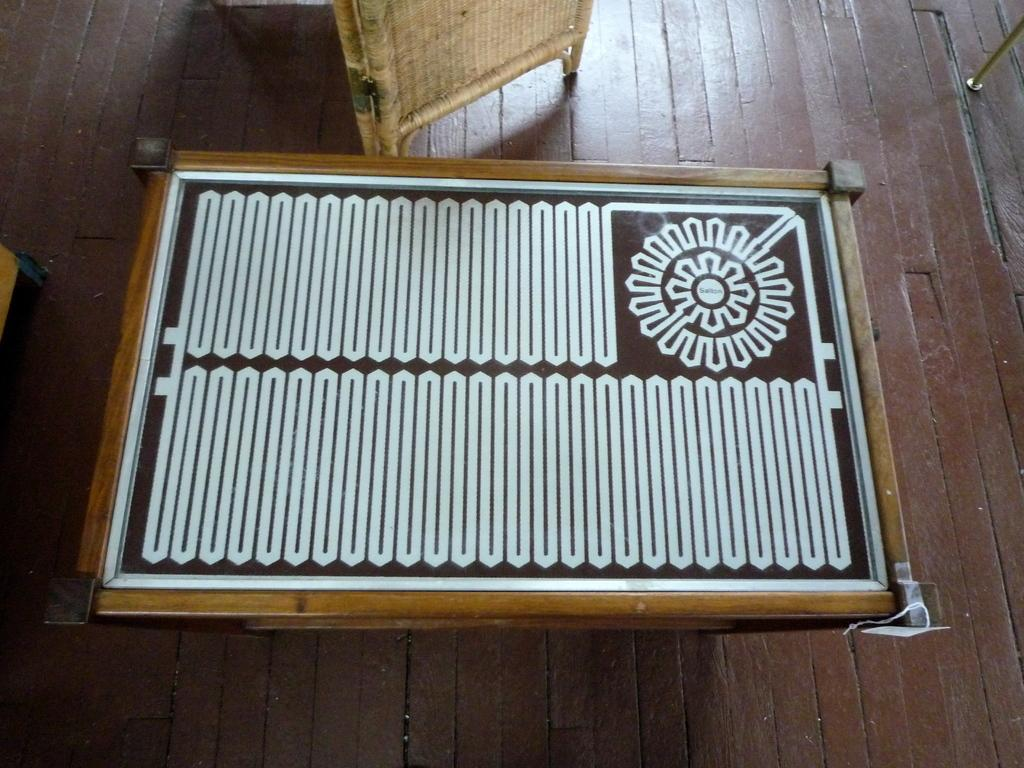What type of furniture is present in the image? There is a table in the image. Where is the table located? The table is on the floor. What other object can be seen beside the table? There is a wooden stand in the image. How is the wooden stand positioned in relation to the table? The wooden stand is beside the table. What type of friction can be observed between the table and the floor in the image? There is no observable friction between the table and the floor in the image. Can you tell me how the table is showing its support for the wooden stand? The table is not actively showing its support for the wooden stand; it is simply present in the image. 